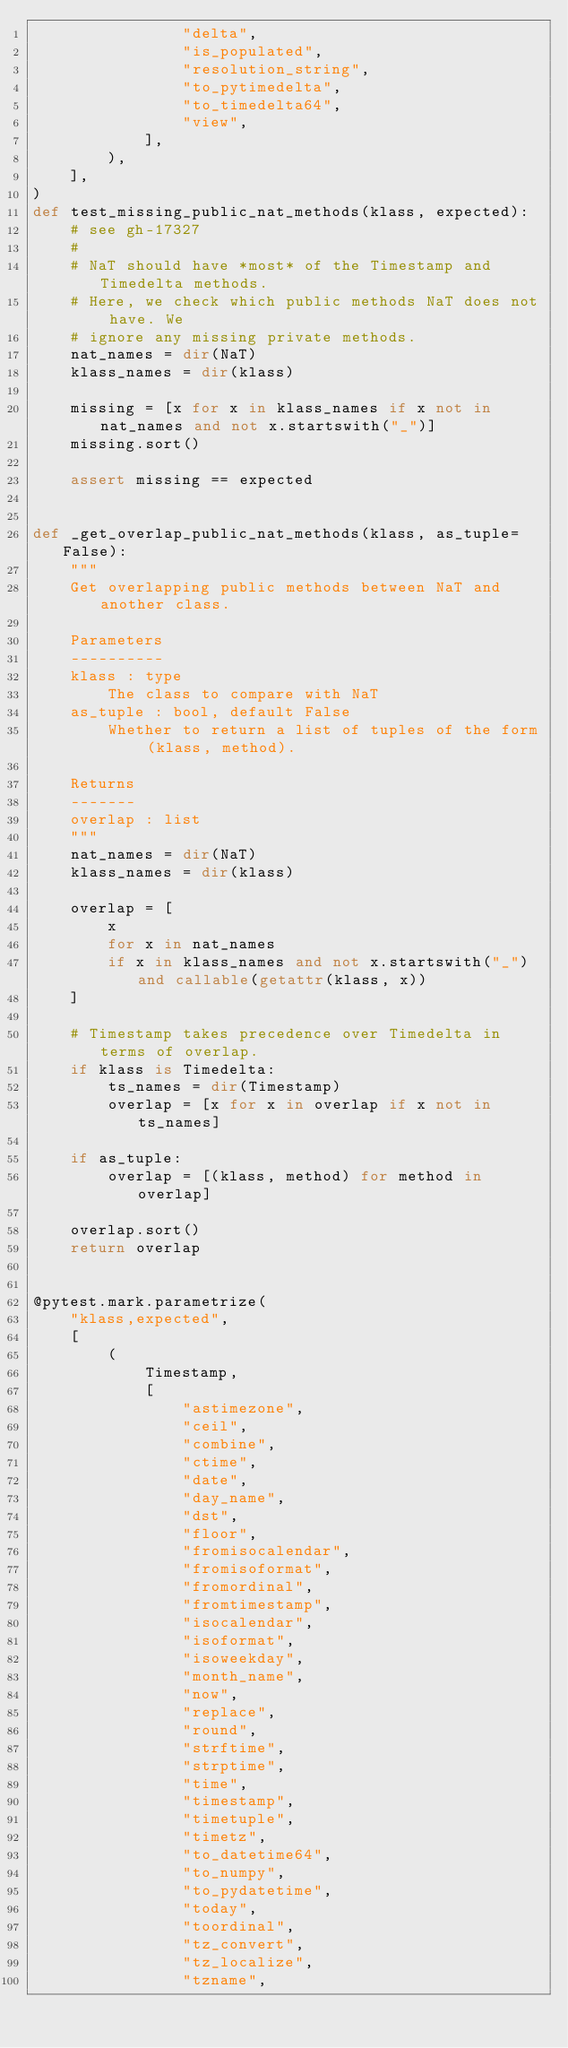Convert code to text. <code><loc_0><loc_0><loc_500><loc_500><_Python_>                "delta",
                "is_populated",
                "resolution_string",
                "to_pytimedelta",
                "to_timedelta64",
                "view",
            ],
        ),
    ],
)
def test_missing_public_nat_methods(klass, expected):
    # see gh-17327
    #
    # NaT should have *most* of the Timestamp and Timedelta methods.
    # Here, we check which public methods NaT does not have. We
    # ignore any missing private methods.
    nat_names = dir(NaT)
    klass_names = dir(klass)

    missing = [x for x in klass_names if x not in nat_names and not x.startswith("_")]
    missing.sort()

    assert missing == expected


def _get_overlap_public_nat_methods(klass, as_tuple=False):
    """
    Get overlapping public methods between NaT and another class.

    Parameters
    ----------
    klass : type
        The class to compare with NaT
    as_tuple : bool, default False
        Whether to return a list of tuples of the form (klass, method).

    Returns
    -------
    overlap : list
    """
    nat_names = dir(NaT)
    klass_names = dir(klass)

    overlap = [
        x
        for x in nat_names
        if x in klass_names and not x.startswith("_") and callable(getattr(klass, x))
    ]

    # Timestamp takes precedence over Timedelta in terms of overlap.
    if klass is Timedelta:
        ts_names = dir(Timestamp)
        overlap = [x for x in overlap if x not in ts_names]

    if as_tuple:
        overlap = [(klass, method) for method in overlap]

    overlap.sort()
    return overlap


@pytest.mark.parametrize(
    "klass,expected",
    [
        (
            Timestamp,
            [
                "astimezone",
                "ceil",
                "combine",
                "ctime",
                "date",
                "day_name",
                "dst",
                "floor",
                "fromisocalendar",
                "fromisoformat",
                "fromordinal",
                "fromtimestamp",
                "isocalendar",
                "isoformat",
                "isoweekday",
                "month_name",
                "now",
                "replace",
                "round",
                "strftime",
                "strptime",
                "time",
                "timestamp",
                "timetuple",
                "timetz",
                "to_datetime64",
                "to_numpy",
                "to_pydatetime",
                "today",
                "toordinal",
                "tz_convert",
                "tz_localize",
                "tzname",</code> 